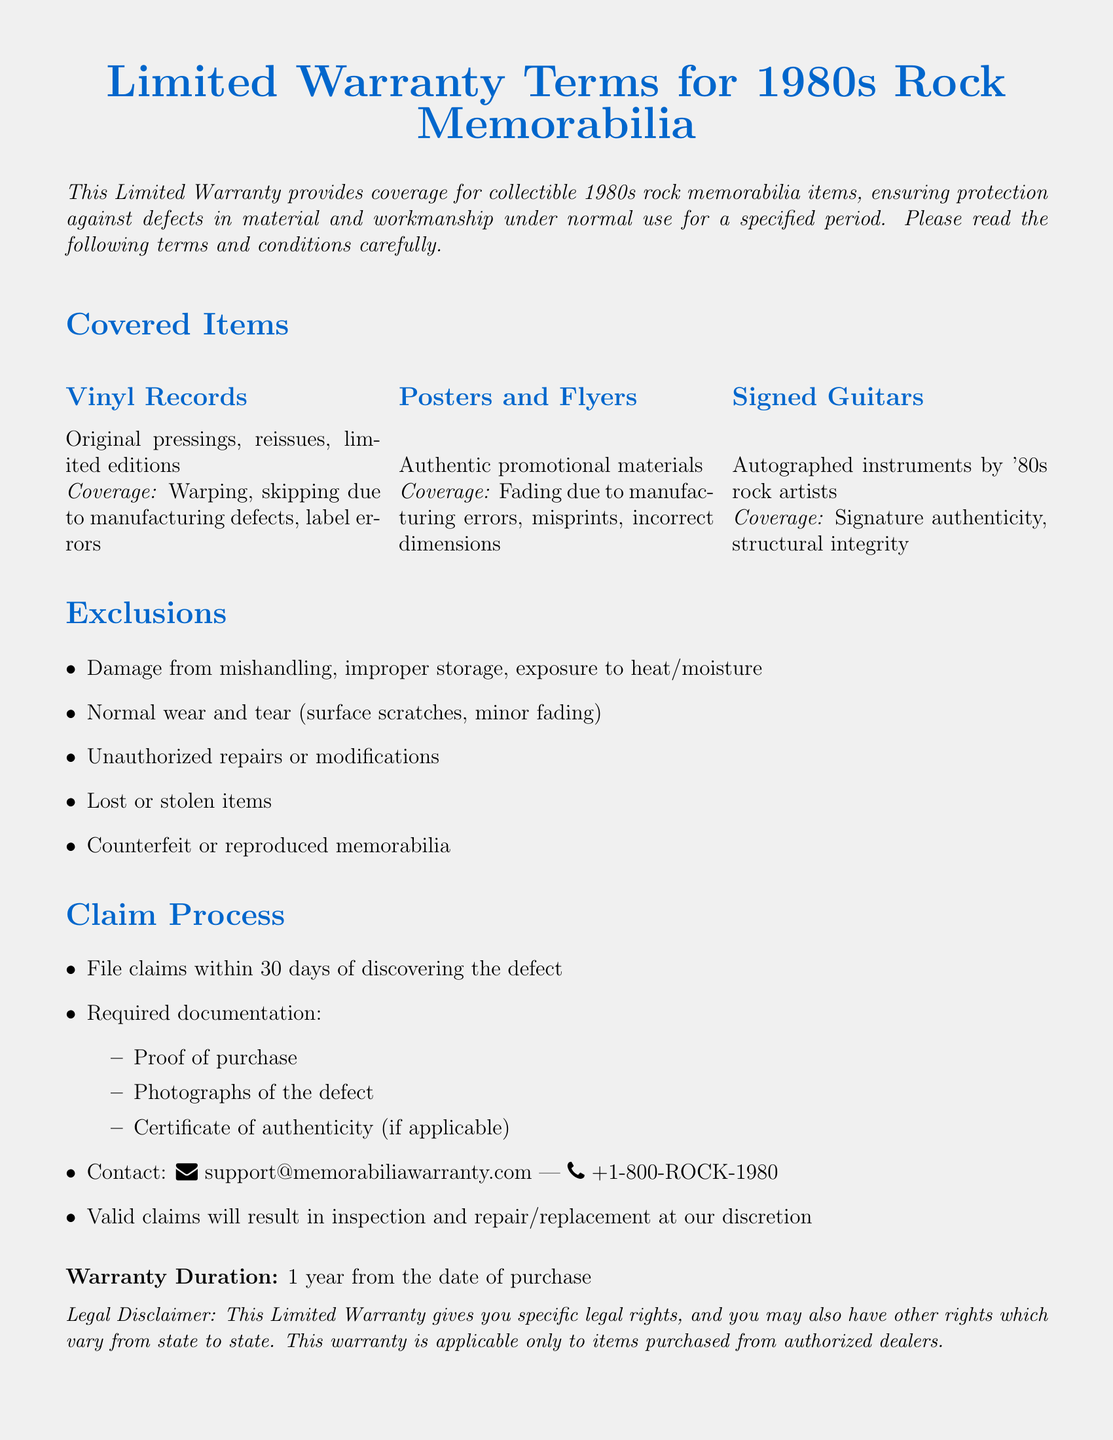What types of items are covered under this warranty? The document lists specific collectible items such as vinyl records, posters, flyers, and signed guitars that fall under the warranty coverage.
Answer: Vinyl records, posters, flyers, signed guitars What is the warranty duration? The warranty duration specifies the length of time the warranty is valid from the purchase date.
Answer: 1 year What must a claimant provide when filing a warranty claim? The document outlines specific documentation that is required to file a claim, including proof of purchase, photographs, and possibly a certificate of authenticity.
Answer: Proof of purchase, photographs, certificate of authenticity What types of damage are excluded from the warranty? The document lists certain damages that are not covered, including mishandling and normal wear and tear among others.
Answer: Damage from mishandling, normal wear and tear What should a claimant do within 30 days of discovering a defect? This indicates a required action that must take place if a defect is discovered within the stipulated time frame.
Answer: File claims What kind of memorabilia has coverage for signature authenticity? The insurance terms specifically highlight certain collectibles that need verification of signature authenticity.
Answer: Signed guitars What is the contact email for warranty support? The document provides a specific email address to contact for support regarding warranty claims.
Answer: support@memorabiliawarranty.com What is not covered due to unauthorized actions? The document mentions types of actions that void coverage, focusing on alterations made without authorization.
Answer: Unauthorized repairs or modifications What is the main purpose of this Limited Warranty? The document describes its intent to protect against defects in collectible items under normal use.
Answer: Protection against defects in material and workmanship 